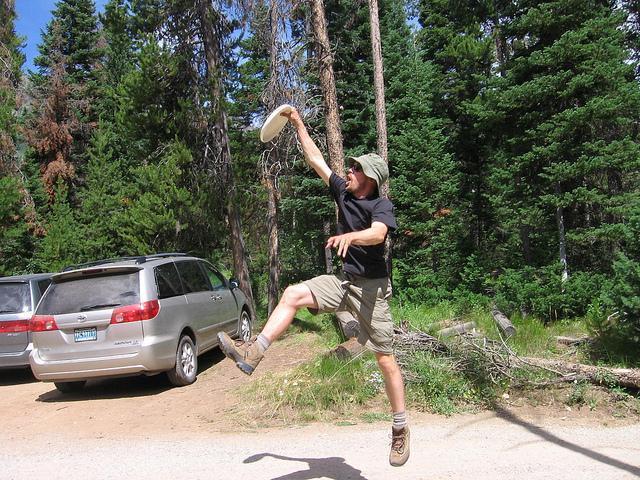How many people can be seen?
Give a very brief answer. 1. How many cars are in the photo?
Give a very brief answer. 2. 